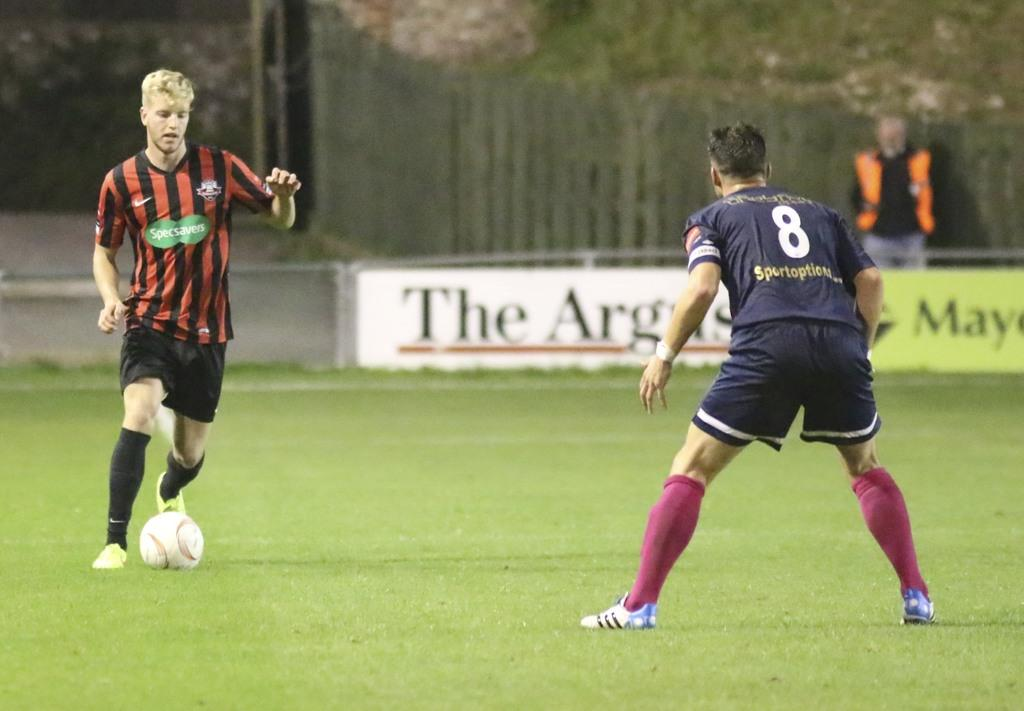What are the two men in the image doing? The two men in the image are playing a game. What object is on the grass in the image? There is a ball on the grass in the image. Can you describe the man in the background of the image? There is a man standing in the background of the image. What can be seen in the background of the image besides the man? There are hoardings and a fence visible in the background of the image. What type of thought can be seen floating above the ball in the image? There is no thought visible in the image, as thoughts are not physical objects that can be seen. 